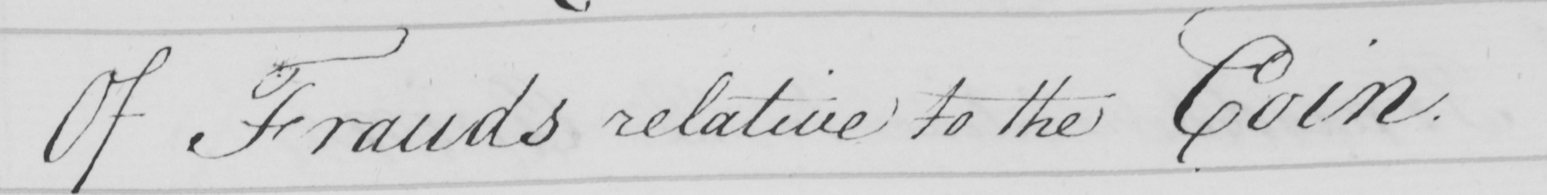Can you tell me what this handwritten text says? Of Frauds relative to the Coin . 